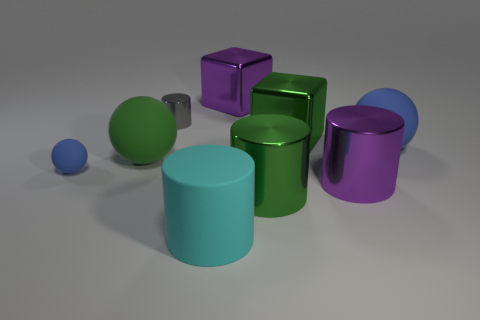Add 1 rubber cylinders. How many objects exist? 10 Subtract all cubes. How many objects are left? 7 Add 4 metal blocks. How many metal blocks exist? 6 Subtract 0 yellow cylinders. How many objects are left? 9 Subtract all tiny blue balls. Subtract all large green rubber objects. How many objects are left? 7 Add 4 small matte balls. How many small matte balls are left? 5 